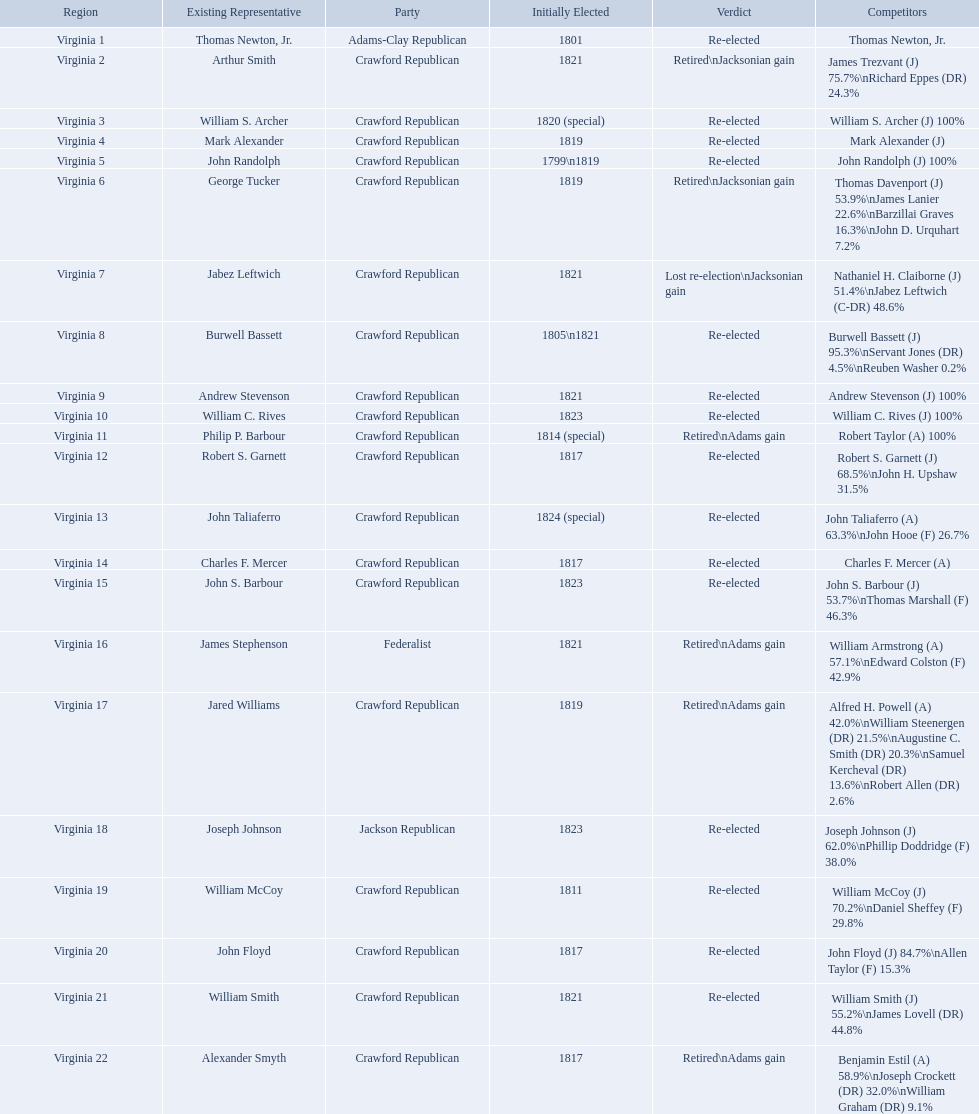Who were the incumbents of the 1824 united states house of representatives elections? Thomas Newton, Jr., Arthur Smith, William S. Archer, Mark Alexander, John Randolph, George Tucker, Jabez Leftwich, Burwell Bassett, Andrew Stevenson, William C. Rives, Philip P. Barbour, Robert S. Garnett, John Taliaferro, Charles F. Mercer, John S. Barbour, James Stephenson, Jared Williams, Joseph Johnson, William McCoy, John Floyd, William Smith, Alexander Smyth. And who were the candidates? Thomas Newton, Jr., James Trezvant (J) 75.7%\nRichard Eppes (DR) 24.3%, William S. Archer (J) 100%, Mark Alexander (J), John Randolph (J) 100%, Thomas Davenport (J) 53.9%\nJames Lanier 22.6%\nBarzillai Graves 16.3%\nJohn D. Urquhart 7.2%, Nathaniel H. Claiborne (J) 51.4%\nJabez Leftwich (C-DR) 48.6%, Burwell Bassett (J) 95.3%\nServant Jones (DR) 4.5%\nReuben Washer 0.2%, Andrew Stevenson (J) 100%, William C. Rives (J) 100%, Robert Taylor (A) 100%, Robert S. Garnett (J) 68.5%\nJohn H. Upshaw 31.5%, John Taliaferro (A) 63.3%\nJohn Hooe (F) 26.7%, Charles F. Mercer (A), John S. Barbour (J) 53.7%\nThomas Marshall (F) 46.3%, William Armstrong (A) 57.1%\nEdward Colston (F) 42.9%, Alfred H. Powell (A) 42.0%\nWilliam Steenergen (DR) 21.5%\nAugustine C. Smith (DR) 20.3%\nSamuel Kercheval (DR) 13.6%\nRobert Allen (DR) 2.6%, Joseph Johnson (J) 62.0%\nPhillip Doddridge (F) 38.0%, William McCoy (J) 70.2%\nDaniel Sheffey (F) 29.8%, John Floyd (J) 84.7%\nAllen Taylor (F) 15.3%, William Smith (J) 55.2%\nJames Lovell (DR) 44.8%, Benjamin Estil (A) 58.9%\nJoseph Crockett (DR) 32.0%\nWilliam Graham (DR) 9.1%. What were the results of their elections? Re-elected, Retired\nJacksonian gain, Re-elected, Re-elected, Re-elected, Retired\nJacksonian gain, Lost re-election\nJacksonian gain, Re-elected, Re-elected, Re-elected, Retired\nAdams gain, Re-elected, Re-elected, Re-elected, Re-elected, Retired\nAdams gain, Retired\nAdams gain, Re-elected, Re-elected, Re-elected, Re-elected, Retired\nAdams gain. And which jacksonian won over 76%? Arthur Smith. What party is a crawford republican? Crawford Republican, Crawford Republican, Crawford Republican, Crawford Republican, Crawford Republican, Crawford Republican, Crawford Republican, Crawford Republican, Crawford Republican, Crawford Republican, Crawford Republican, Crawford Republican, Crawford Republican, Crawford Republican, Crawford Republican, Crawford Republican, Crawford Republican, Crawford Republican, Crawford Republican. What candidates have over 76%? James Trezvant (J) 75.7%\nRichard Eppes (DR) 24.3%, William S. Archer (J) 100%, John Randolph (J) 100%, Burwell Bassett (J) 95.3%\nServant Jones (DR) 4.5%\nReuben Washer 0.2%, Andrew Stevenson (J) 100%, William C. Rives (J) 100%, Robert Taylor (A) 100%, John Floyd (J) 84.7%\nAllen Taylor (F) 15.3%. Which result was retired jacksonian gain? Retired\nJacksonian gain. Who was the incumbent? Arthur Smith. 